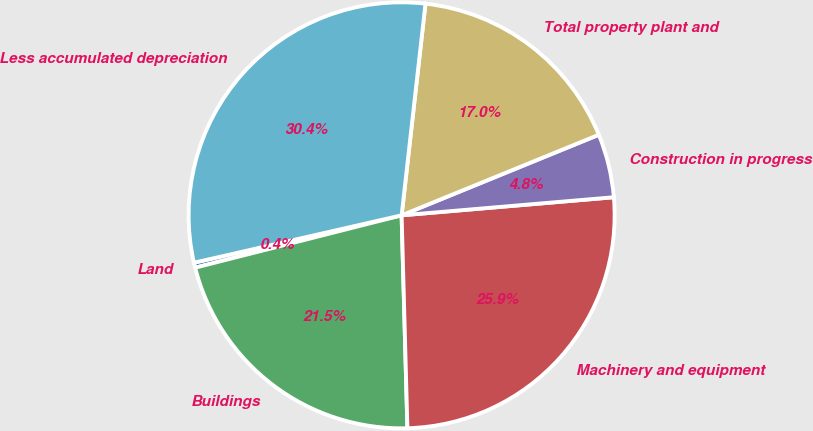Convert chart. <chart><loc_0><loc_0><loc_500><loc_500><pie_chart><fcel>Land<fcel>Buildings<fcel>Machinery and equipment<fcel>Construction in progress<fcel>Total property plant and<fcel>Less accumulated depreciation<nl><fcel>0.38%<fcel>21.48%<fcel>25.92%<fcel>4.82%<fcel>17.04%<fcel>30.36%<nl></chart> 